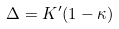Convert formula to latex. <formula><loc_0><loc_0><loc_500><loc_500>\Delta = K ^ { \prime } ( 1 - \kappa )</formula> 